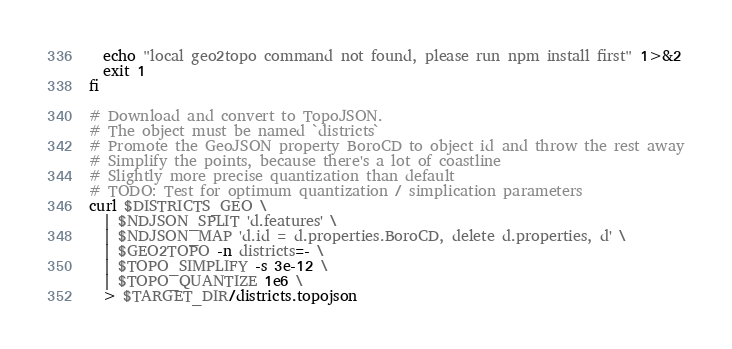Convert code to text. <code><loc_0><loc_0><loc_500><loc_500><_Bash_>  echo "local geo2topo command not found, please run npm install first" 1>&2
  exit 1
fi

# Download and convert to TopoJSON.
# The object must be named `districts`
# Promote the GeoJSON property BoroCD to object id and throw the rest away
# Simplify the points, because there's a lot of coastline
# Slightly more precise quantization than default
# TODO: Test for optimum quantization / simplication parameters
curl $DISTRICTS_GEO \
  | $NDJSON_SPLIT 'd.features' \
  | $NDJSON_MAP 'd.id = d.properties.BoroCD, delete d.properties, d' \
  | $GEO2TOPO -n districts=- \
  | $TOPO_SIMPLIFY -s 3e-12 \
  | $TOPO_QUANTIZE 1e6 \
  > $TARGET_DIR/districts.topojson
</code> 